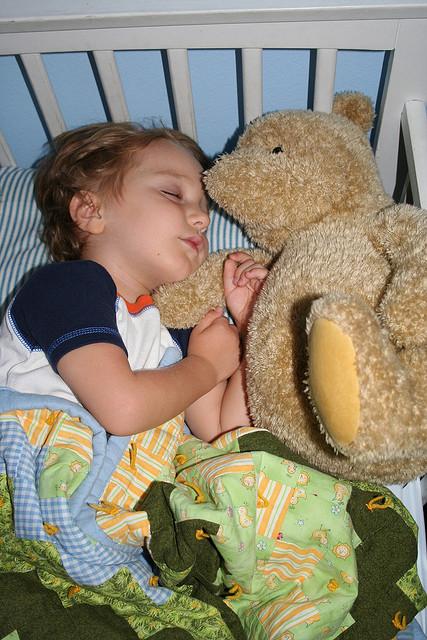Is the baby walking?
Be succinct. No. Will the baby want to keep this bear for life?
Answer briefly. Yes. What is the pattern of his bed sheets?
Short answer required. Stripes. 